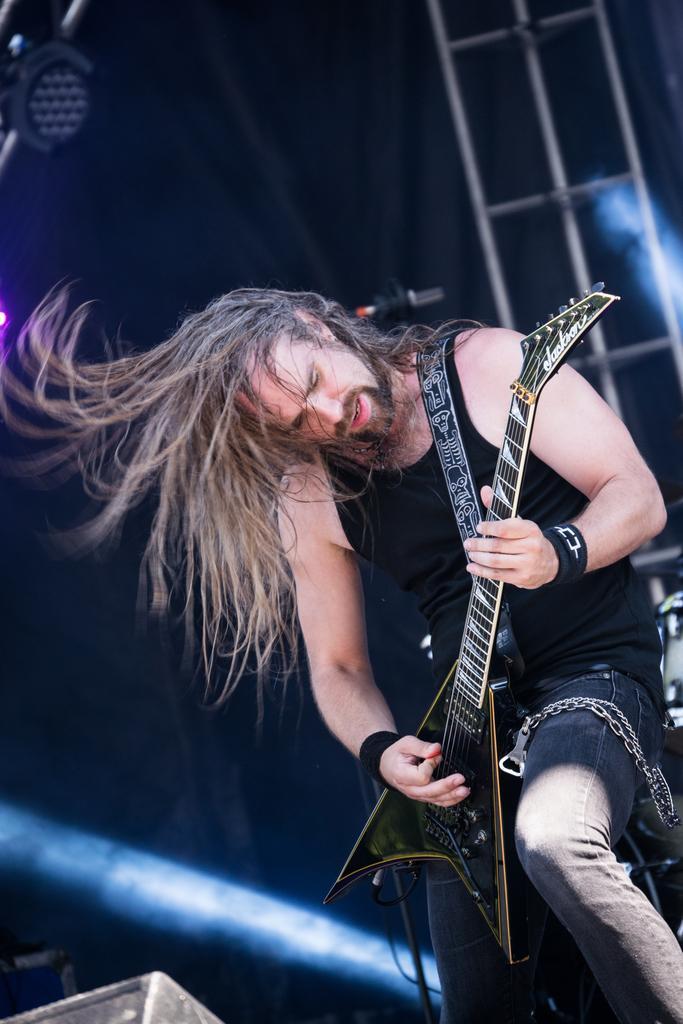Could you give a brief overview of what you see in this image? As we can see in the image, there is a man holding guitar. 